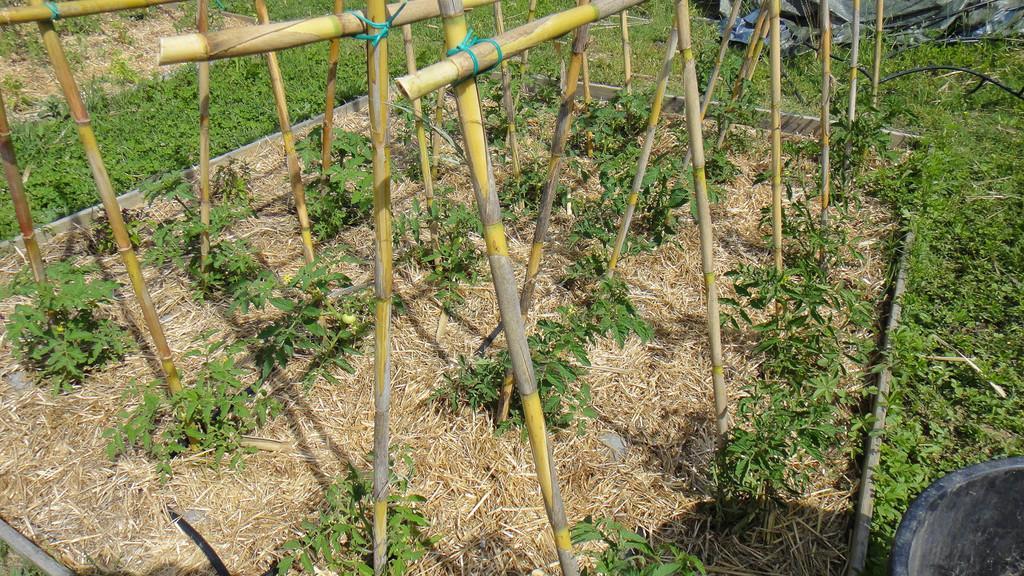How would you summarize this image in a sentence or two? In the image on the ground there is grass and also there are small plants. And also there are wooden poles. In the bottom right corner of the image there is a black color object. At the top of the image in the background on the ground there is cover. 